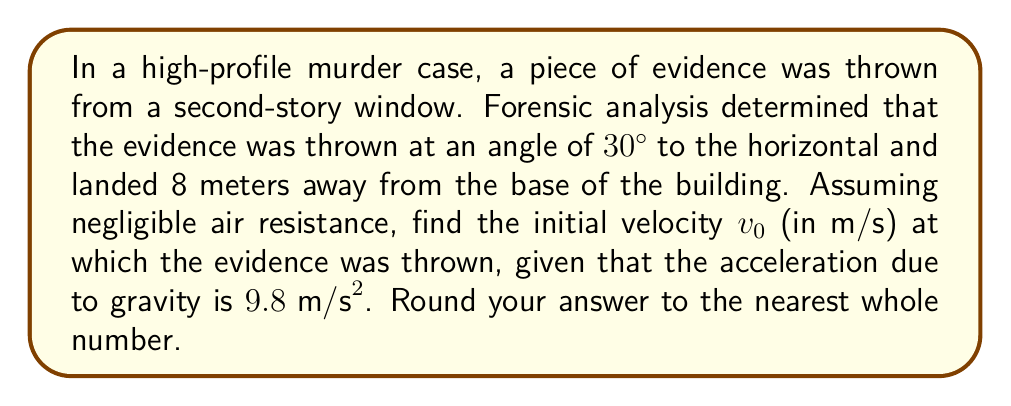Can you answer this question? Let's approach this step-by-step using the principles of projectile motion:

1) First, we need to recall the equations of motion for projectile trajectories:

   Horizontal motion: $x = v_0 \cos(\theta) t$
   Vertical motion: $y = v_0 \sin(\theta) t - \frac{1}{2}gt^2$

   Where $x$ is the horizontal distance, $y$ is the vertical distance, $v_0$ is the initial velocity, $\theta$ is the angle of projection, $t$ is time, and $g$ is acceleration due to gravity.

2) We know that $x = 8$ meters (the horizontal distance), $\theta = 30°$, and $g = 9.8 \text{ m/s}^2$.

3) We also know that when the evidence hits the ground, $y = 0$. We can use this to eliminate $t$ from our equations.

4) From the horizontal motion equation:
   $t = \frac{x}{v_0 \cos(\theta)} = \frac{8}{v_0 \cos(30°)}$

5) Substituting this into the vertical motion equation:
   $0 = v_0 \sin(30°) (\frac{8}{v_0 \cos(30°)}) - \frac{1}{2}g(\frac{8}{v_0 \cos(30°)})^2$

6) Simplify:
   $0 = \frac{8 \tan(30°)}{v_0} - \frac{32g}{v_0^2 \cos^2(30°)}$

7) Multiply both sides by $v_0^2 \cos^2(30°)$:
   $0 = 8v_0 \tan(30°) \cos^2(30°) - 32g$

8) Solve for $v_0$:
   $v_0 = \sqrt{\frac{32g}{8 \tan(30°) \cos^2(30°)}}$

9) Substitute known values:
   $v_0 = \sqrt{\frac{32 \cdot 9.8}{8 \tan(30°) \cos^2(30°)}} \approx 13.86 \text{ m/s}$

10) Rounding to the nearest whole number:
    $v_0 \approx 14 \text{ m/s}$
Answer: $14 \text{ m/s}$ 